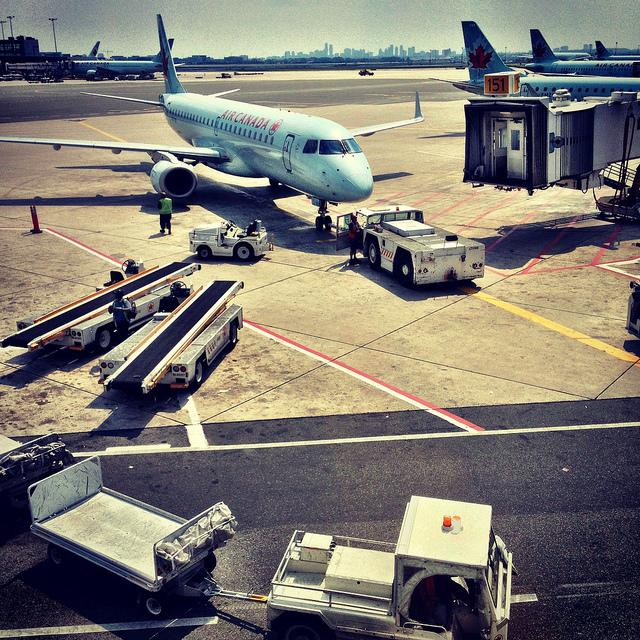What does the vehicle that will be used to move the plane face? Please explain your reasoning. plane. This pushback will connect to the wheel of this large flying vehicle to move it. 